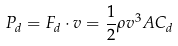<formula> <loc_0><loc_0><loc_500><loc_500>P _ { d } = F _ { d } \cdot v = { \frac { 1 } { 2 } } \rho v ^ { 3 } A C _ { d }</formula> 